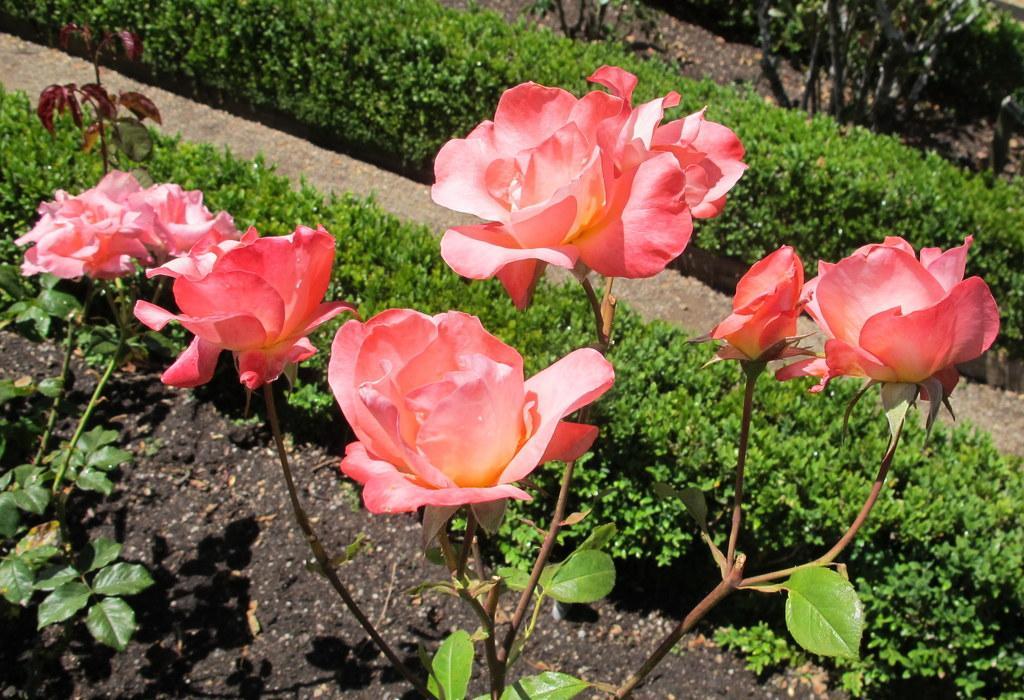Can you describe this image briefly? In this image, we can see some pink flowers and we can see some plants. 